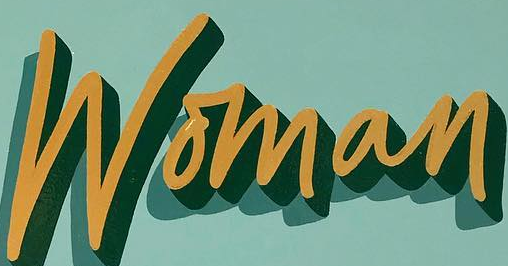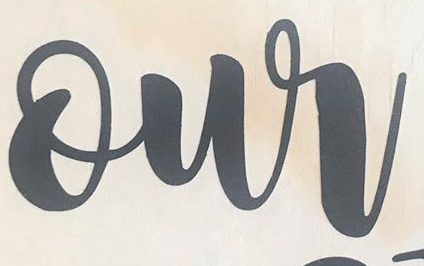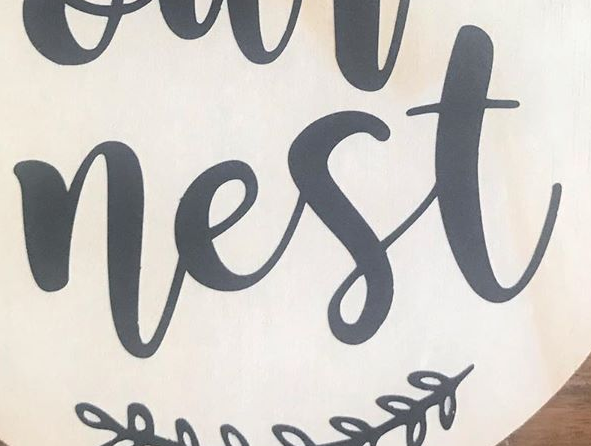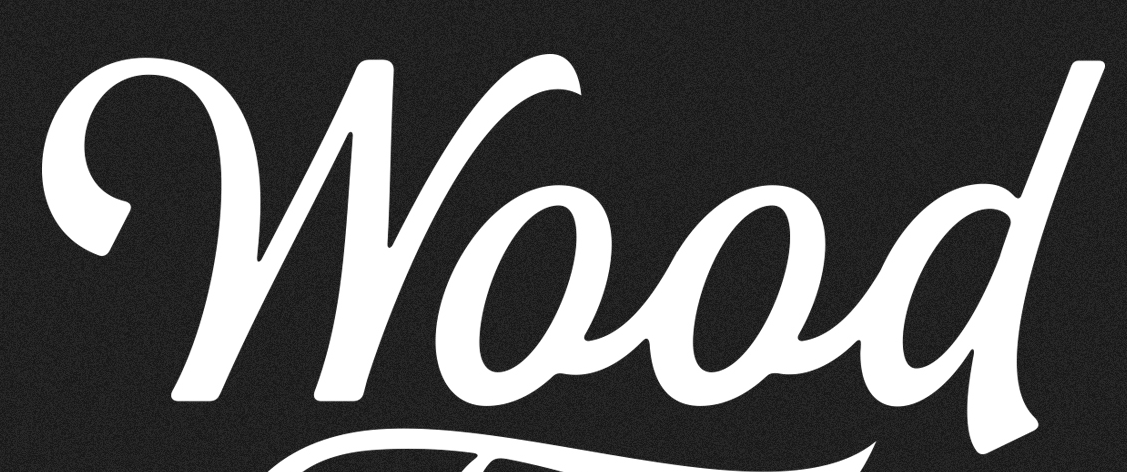Read the text from these images in sequence, separated by a semicolon. Woman; our; nest; Wood 